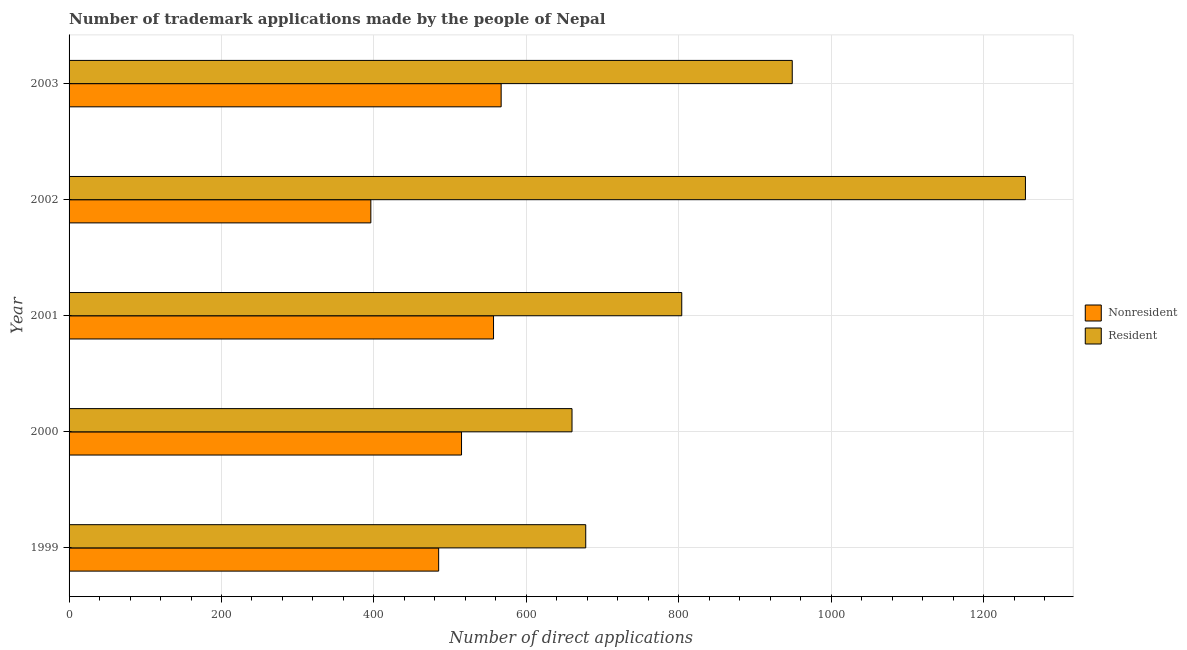How many different coloured bars are there?
Your answer should be very brief. 2. How many groups of bars are there?
Give a very brief answer. 5. Are the number of bars per tick equal to the number of legend labels?
Your answer should be compact. Yes. Are the number of bars on each tick of the Y-axis equal?
Provide a succinct answer. Yes. How many bars are there on the 5th tick from the top?
Make the answer very short. 2. How many bars are there on the 5th tick from the bottom?
Give a very brief answer. 2. What is the number of trademark applications made by residents in 2001?
Your answer should be very brief. 804. Across all years, what is the maximum number of trademark applications made by residents?
Provide a short and direct response. 1255. Across all years, what is the minimum number of trademark applications made by residents?
Your answer should be compact. 660. In which year was the number of trademark applications made by non residents maximum?
Ensure brevity in your answer.  2003. In which year was the number of trademark applications made by non residents minimum?
Your response must be concise. 2002. What is the total number of trademark applications made by non residents in the graph?
Your answer should be very brief. 2520. What is the difference between the number of trademark applications made by non residents in 2000 and that in 2001?
Offer a terse response. -42. What is the difference between the number of trademark applications made by residents in 2002 and the number of trademark applications made by non residents in 2001?
Offer a terse response. 698. What is the average number of trademark applications made by non residents per year?
Provide a succinct answer. 504. In the year 2000, what is the difference between the number of trademark applications made by residents and number of trademark applications made by non residents?
Keep it short and to the point. 145. What is the ratio of the number of trademark applications made by residents in 1999 to that in 2003?
Your response must be concise. 0.71. Is the number of trademark applications made by non residents in 1999 less than that in 2000?
Your answer should be compact. Yes. Is the difference between the number of trademark applications made by non residents in 2000 and 2003 greater than the difference between the number of trademark applications made by residents in 2000 and 2003?
Keep it short and to the point. Yes. What is the difference between the highest and the second highest number of trademark applications made by non residents?
Provide a succinct answer. 10. What is the difference between the highest and the lowest number of trademark applications made by residents?
Give a very brief answer. 595. In how many years, is the number of trademark applications made by residents greater than the average number of trademark applications made by residents taken over all years?
Ensure brevity in your answer.  2. Is the sum of the number of trademark applications made by non residents in 2001 and 2003 greater than the maximum number of trademark applications made by residents across all years?
Your answer should be compact. No. What does the 2nd bar from the top in 2001 represents?
Your response must be concise. Nonresident. What does the 1st bar from the bottom in 2000 represents?
Your answer should be very brief. Nonresident. Are all the bars in the graph horizontal?
Ensure brevity in your answer.  Yes. What is the difference between two consecutive major ticks on the X-axis?
Your answer should be very brief. 200. Does the graph contain grids?
Provide a succinct answer. Yes. What is the title of the graph?
Provide a short and direct response. Number of trademark applications made by the people of Nepal. Does "Travel services" appear as one of the legend labels in the graph?
Your response must be concise. No. What is the label or title of the X-axis?
Your answer should be very brief. Number of direct applications. What is the label or title of the Y-axis?
Provide a short and direct response. Year. What is the Number of direct applications of Nonresident in 1999?
Give a very brief answer. 485. What is the Number of direct applications of Resident in 1999?
Offer a terse response. 678. What is the Number of direct applications of Nonresident in 2000?
Keep it short and to the point. 515. What is the Number of direct applications in Resident in 2000?
Offer a terse response. 660. What is the Number of direct applications of Nonresident in 2001?
Provide a succinct answer. 557. What is the Number of direct applications in Resident in 2001?
Your answer should be very brief. 804. What is the Number of direct applications in Nonresident in 2002?
Provide a short and direct response. 396. What is the Number of direct applications of Resident in 2002?
Your response must be concise. 1255. What is the Number of direct applications in Nonresident in 2003?
Keep it short and to the point. 567. What is the Number of direct applications in Resident in 2003?
Your answer should be very brief. 949. Across all years, what is the maximum Number of direct applications in Nonresident?
Your answer should be very brief. 567. Across all years, what is the maximum Number of direct applications of Resident?
Keep it short and to the point. 1255. Across all years, what is the minimum Number of direct applications in Nonresident?
Offer a very short reply. 396. Across all years, what is the minimum Number of direct applications of Resident?
Ensure brevity in your answer.  660. What is the total Number of direct applications of Nonresident in the graph?
Provide a short and direct response. 2520. What is the total Number of direct applications in Resident in the graph?
Your answer should be very brief. 4346. What is the difference between the Number of direct applications in Nonresident in 1999 and that in 2001?
Your answer should be compact. -72. What is the difference between the Number of direct applications of Resident in 1999 and that in 2001?
Give a very brief answer. -126. What is the difference between the Number of direct applications of Nonresident in 1999 and that in 2002?
Give a very brief answer. 89. What is the difference between the Number of direct applications of Resident in 1999 and that in 2002?
Your answer should be compact. -577. What is the difference between the Number of direct applications in Nonresident in 1999 and that in 2003?
Your answer should be compact. -82. What is the difference between the Number of direct applications of Resident in 1999 and that in 2003?
Your response must be concise. -271. What is the difference between the Number of direct applications of Nonresident in 2000 and that in 2001?
Offer a very short reply. -42. What is the difference between the Number of direct applications in Resident in 2000 and that in 2001?
Provide a succinct answer. -144. What is the difference between the Number of direct applications of Nonresident in 2000 and that in 2002?
Give a very brief answer. 119. What is the difference between the Number of direct applications in Resident in 2000 and that in 2002?
Your answer should be compact. -595. What is the difference between the Number of direct applications of Nonresident in 2000 and that in 2003?
Ensure brevity in your answer.  -52. What is the difference between the Number of direct applications in Resident in 2000 and that in 2003?
Keep it short and to the point. -289. What is the difference between the Number of direct applications of Nonresident in 2001 and that in 2002?
Offer a very short reply. 161. What is the difference between the Number of direct applications of Resident in 2001 and that in 2002?
Provide a succinct answer. -451. What is the difference between the Number of direct applications of Nonresident in 2001 and that in 2003?
Your answer should be very brief. -10. What is the difference between the Number of direct applications in Resident in 2001 and that in 2003?
Make the answer very short. -145. What is the difference between the Number of direct applications of Nonresident in 2002 and that in 2003?
Provide a short and direct response. -171. What is the difference between the Number of direct applications of Resident in 2002 and that in 2003?
Provide a succinct answer. 306. What is the difference between the Number of direct applications of Nonresident in 1999 and the Number of direct applications of Resident in 2000?
Your answer should be very brief. -175. What is the difference between the Number of direct applications of Nonresident in 1999 and the Number of direct applications of Resident in 2001?
Keep it short and to the point. -319. What is the difference between the Number of direct applications in Nonresident in 1999 and the Number of direct applications in Resident in 2002?
Provide a short and direct response. -770. What is the difference between the Number of direct applications of Nonresident in 1999 and the Number of direct applications of Resident in 2003?
Your answer should be compact. -464. What is the difference between the Number of direct applications of Nonresident in 2000 and the Number of direct applications of Resident in 2001?
Offer a very short reply. -289. What is the difference between the Number of direct applications of Nonresident in 2000 and the Number of direct applications of Resident in 2002?
Your response must be concise. -740. What is the difference between the Number of direct applications of Nonresident in 2000 and the Number of direct applications of Resident in 2003?
Your answer should be compact. -434. What is the difference between the Number of direct applications in Nonresident in 2001 and the Number of direct applications in Resident in 2002?
Offer a very short reply. -698. What is the difference between the Number of direct applications of Nonresident in 2001 and the Number of direct applications of Resident in 2003?
Provide a succinct answer. -392. What is the difference between the Number of direct applications of Nonresident in 2002 and the Number of direct applications of Resident in 2003?
Provide a succinct answer. -553. What is the average Number of direct applications of Nonresident per year?
Keep it short and to the point. 504. What is the average Number of direct applications in Resident per year?
Provide a succinct answer. 869.2. In the year 1999, what is the difference between the Number of direct applications in Nonresident and Number of direct applications in Resident?
Give a very brief answer. -193. In the year 2000, what is the difference between the Number of direct applications in Nonresident and Number of direct applications in Resident?
Your answer should be compact. -145. In the year 2001, what is the difference between the Number of direct applications in Nonresident and Number of direct applications in Resident?
Your answer should be compact. -247. In the year 2002, what is the difference between the Number of direct applications of Nonresident and Number of direct applications of Resident?
Offer a terse response. -859. In the year 2003, what is the difference between the Number of direct applications in Nonresident and Number of direct applications in Resident?
Keep it short and to the point. -382. What is the ratio of the Number of direct applications in Nonresident in 1999 to that in 2000?
Give a very brief answer. 0.94. What is the ratio of the Number of direct applications in Resident in 1999 to that in 2000?
Your response must be concise. 1.03. What is the ratio of the Number of direct applications of Nonresident in 1999 to that in 2001?
Keep it short and to the point. 0.87. What is the ratio of the Number of direct applications of Resident in 1999 to that in 2001?
Your response must be concise. 0.84. What is the ratio of the Number of direct applications of Nonresident in 1999 to that in 2002?
Your answer should be very brief. 1.22. What is the ratio of the Number of direct applications of Resident in 1999 to that in 2002?
Your response must be concise. 0.54. What is the ratio of the Number of direct applications of Nonresident in 1999 to that in 2003?
Provide a succinct answer. 0.86. What is the ratio of the Number of direct applications of Resident in 1999 to that in 2003?
Offer a terse response. 0.71. What is the ratio of the Number of direct applications of Nonresident in 2000 to that in 2001?
Offer a terse response. 0.92. What is the ratio of the Number of direct applications of Resident in 2000 to that in 2001?
Provide a short and direct response. 0.82. What is the ratio of the Number of direct applications in Nonresident in 2000 to that in 2002?
Offer a terse response. 1.3. What is the ratio of the Number of direct applications in Resident in 2000 to that in 2002?
Your answer should be very brief. 0.53. What is the ratio of the Number of direct applications in Nonresident in 2000 to that in 2003?
Your answer should be very brief. 0.91. What is the ratio of the Number of direct applications in Resident in 2000 to that in 2003?
Ensure brevity in your answer.  0.7. What is the ratio of the Number of direct applications in Nonresident in 2001 to that in 2002?
Provide a succinct answer. 1.41. What is the ratio of the Number of direct applications of Resident in 2001 to that in 2002?
Your response must be concise. 0.64. What is the ratio of the Number of direct applications in Nonresident in 2001 to that in 2003?
Your answer should be very brief. 0.98. What is the ratio of the Number of direct applications in Resident in 2001 to that in 2003?
Give a very brief answer. 0.85. What is the ratio of the Number of direct applications in Nonresident in 2002 to that in 2003?
Make the answer very short. 0.7. What is the ratio of the Number of direct applications in Resident in 2002 to that in 2003?
Ensure brevity in your answer.  1.32. What is the difference between the highest and the second highest Number of direct applications in Nonresident?
Ensure brevity in your answer.  10. What is the difference between the highest and the second highest Number of direct applications in Resident?
Provide a succinct answer. 306. What is the difference between the highest and the lowest Number of direct applications of Nonresident?
Make the answer very short. 171. What is the difference between the highest and the lowest Number of direct applications of Resident?
Provide a short and direct response. 595. 